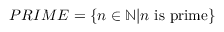Convert formula to latex. <formula><loc_0><loc_0><loc_500><loc_500>P R I M E = \{ n \in \mathbb { N } | n { i s p r i m e } \}</formula> 